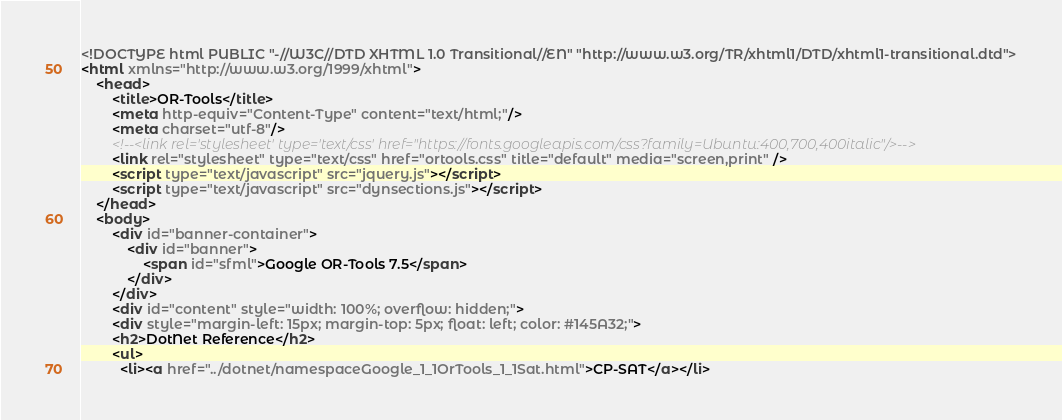<code> <loc_0><loc_0><loc_500><loc_500><_HTML_><!DOCTYPE html PUBLIC "-//W3C//DTD XHTML 1.0 Transitional//EN" "http://www.w3.org/TR/xhtml1/DTD/xhtml1-transitional.dtd">
<html xmlns="http://www.w3.org/1999/xhtml">
    <head>
        <title>OR-Tools</title>
        <meta http-equiv="Content-Type" content="text/html;"/>
        <meta charset="utf-8"/>
        <!--<link rel='stylesheet' type='text/css' href="https://fonts.googleapis.com/css?family=Ubuntu:400,700,400italic"/>-->
        <link rel="stylesheet" type="text/css" href="ortools.css" title="default" media="screen,print" />
        <script type="text/javascript" src="jquery.js"></script>
        <script type="text/javascript" src="dynsections.js"></script>
    </head>
    <body>
        <div id="banner-container">
            <div id="banner">
                <span id="sfml">Google OR-Tools 7.5</span>
            </div>
        </div>
        <div id="content" style="width: 100%; overflow: hidden;">
        <div style="margin-left: 15px; margin-top: 5px; float: left; color: #145A32;">
        <h2>DotNet Reference</h2>
        <ul>
          <li><a href="../dotnet/namespaceGoogle_1_1OrTools_1_1Sat.html">CP-SAT</a></li></code> 